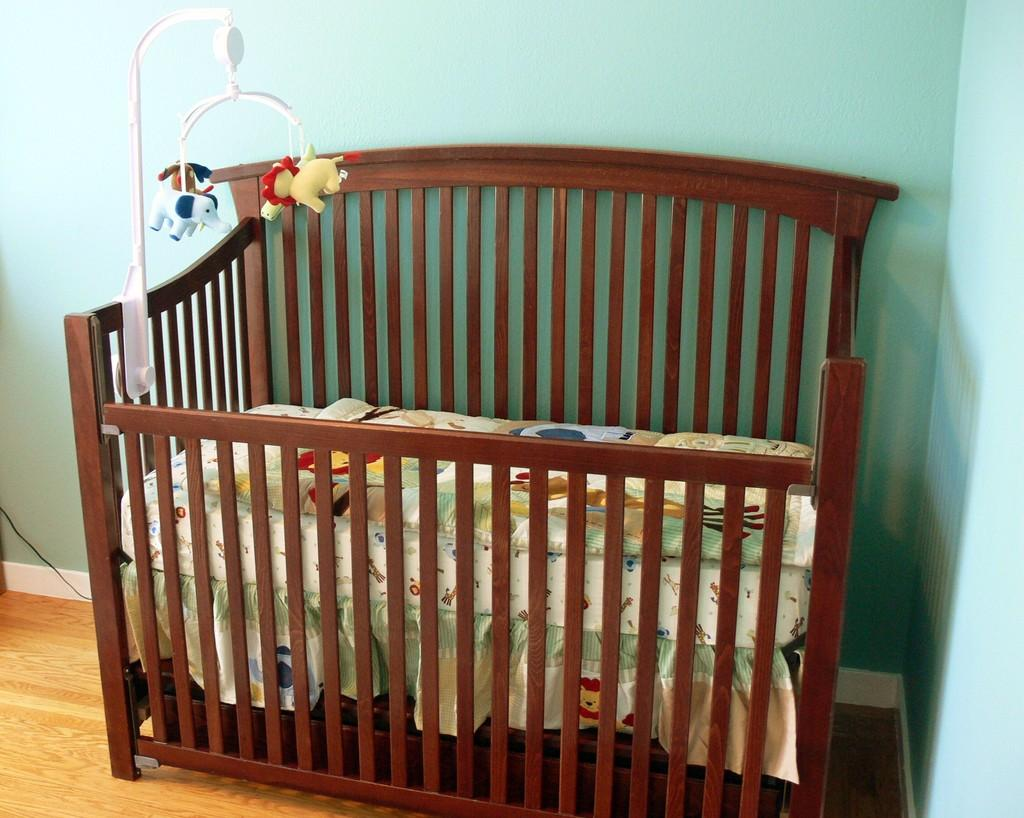What is the main object in the image? There is a cradle in the image. What other item can be seen in the image? There is a toy in the image. What is visible in the background of the image? There is a wall in the background of the image. What type of substance can be seen covering the ground in the image? There is no substance covering the ground in the image; it only features a cradle, a toy, and a wall in the background. 